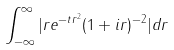Convert formula to latex. <formula><loc_0><loc_0><loc_500><loc_500>\int _ { - \infty } ^ { \infty } | r e ^ { - t r ^ { 2 } } ( 1 + i r ) ^ { - 2 } | d r</formula> 